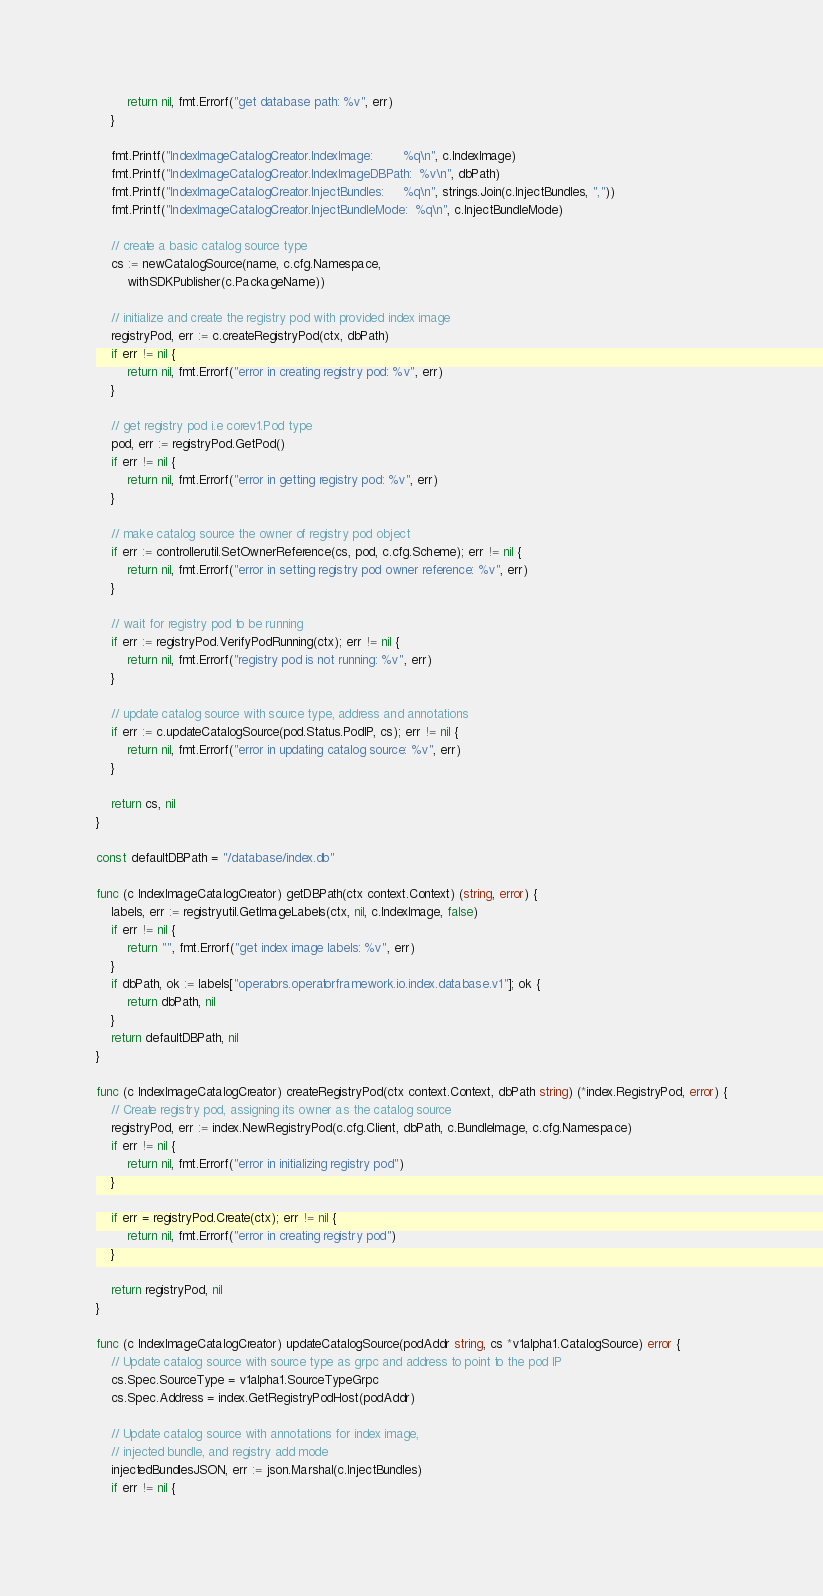<code> <loc_0><loc_0><loc_500><loc_500><_Go_>		return nil, fmt.Errorf("get database path: %v", err)
	}

	fmt.Printf("IndexImageCatalogCreator.IndexImage:        %q\n", c.IndexImage)
	fmt.Printf("IndexImageCatalogCreator.IndexImageDBPath:  %v\n", dbPath)
	fmt.Printf("IndexImageCatalogCreator.InjectBundles:     %q\n", strings.Join(c.InjectBundles, ","))
	fmt.Printf("IndexImageCatalogCreator.InjectBundleMode:  %q\n", c.InjectBundleMode)

	// create a basic catalog source type
	cs := newCatalogSource(name, c.cfg.Namespace,
		withSDKPublisher(c.PackageName))

	// initialize and create the registry pod with provided index image
	registryPod, err := c.createRegistryPod(ctx, dbPath)
	if err != nil {
		return nil, fmt.Errorf("error in creating registry pod: %v", err)
	}

	// get registry pod i.e corev1.Pod type
	pod, err := registryPod.GetPod()
	if err != nil {
		return nil, fmt.Errorf("error in getting registry pod: %v", err)
	}

	// make catalog source the owner of registry pod object
	if err := controllerutil.SetOwnerReference(cs, pod, c.cfg.Scheme); err != nil {
		return nil, fmt.Errorf("error in setting registry pod owner reference: %v", err)
	}

	// wait for registry pod to be running
	if err := registryPod.VerifyPodRunning(ctx); err != nil {
		return nil, fmt.Errorf("registry pod is not running: %v", err)
	}

	// update catalog source with source type, address and annotations
	if err := c.updateCatalogSource(pod.Status.PodIP, cs); err != nil {
		return nil, fmt.Errorf("error in updating catalog source: %v", err)
	}

	return cs, nil
}

const defaultDBPath = "/database/index.db"

func (c IndexImageCatalogCreator) getDBPath(ctx context.Context) (string, error) {
	labels, err := registryutil.GetImageLabels(ctx, nil, c.IndexImage, false)
	if err != nil {
		return "", fmt.Errorf("get index image labels: %v", err)
	}
	if dbPath, ok := labels["operators.operatorframework.io.index.database.v1"]; ok {
		return dbPath, nil
	}
	return defaultDBPath, nil
}

func (c IndexImageCatalogCreator) createRegistryPod(ctx context.Context, dbPath string) (*index.RegistryPod, error) {
	// Create registry pod, assigning its owner as the catalog source
	registryPod, err := index.NewRegistryPod(c.cfg.Client, dbPath, c.BundleImage, c.cfg.Namespace)
	if err != nil {
		return nil, fmt.Errorf("error in initializing registry pod")
	}

	if err = registryPod.Create(ctx); err != nil {
		return nil, fmt.Errorf("error in creating registry pod")
	}

	return registryPod, nil
}

func (c IndexImageCatalogCreator) updateCatalogSource(podAddr string, cs *v1alpha1.CatalogSource) error {
	// Update catalog source with source type as grpc and address to point to the pod IP
	cs.Spec.SourceType = v1alpha1.SourceTypeGrpc
	cs.Spec.Address = index.GetRegistryPodHost(podAddr)

	// Update catalog source with annotations for index image,
	// injected bundle, and registry add mode
	injectedBundlesJSON, err := json.Marshal(c.InjectBundles)
	if err != nil {</code> 